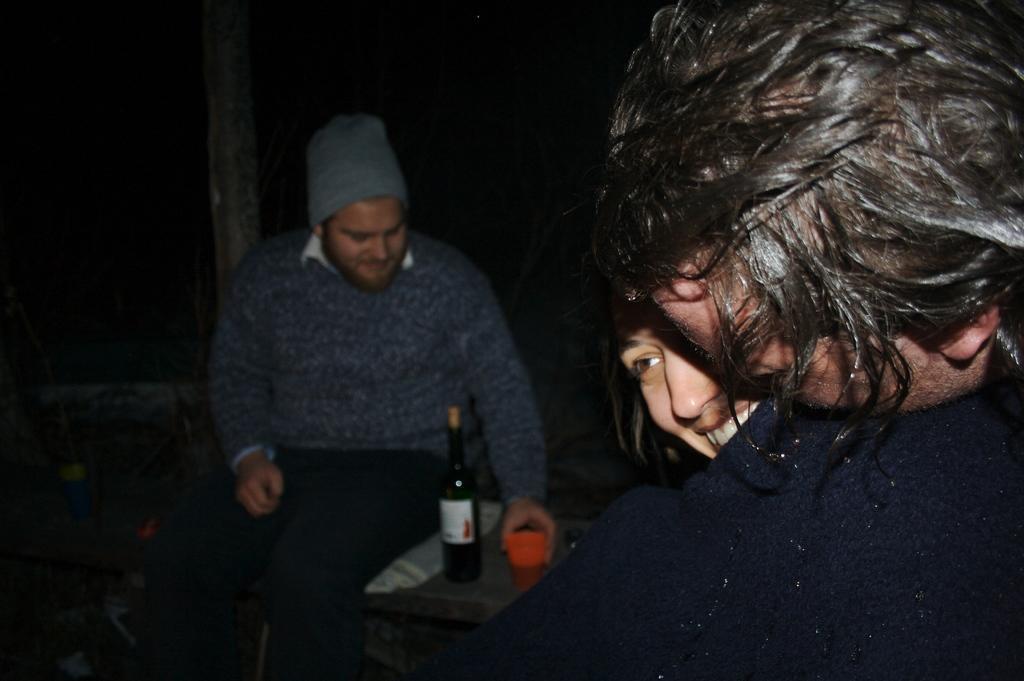Please provide a concise description of this image. In the foreground there are two persons holding blanket. The background is blurred. In the center of the picture there is a person sitting on the bench, on the bench there is a cup and bottle. Beside the person there is a pole. 